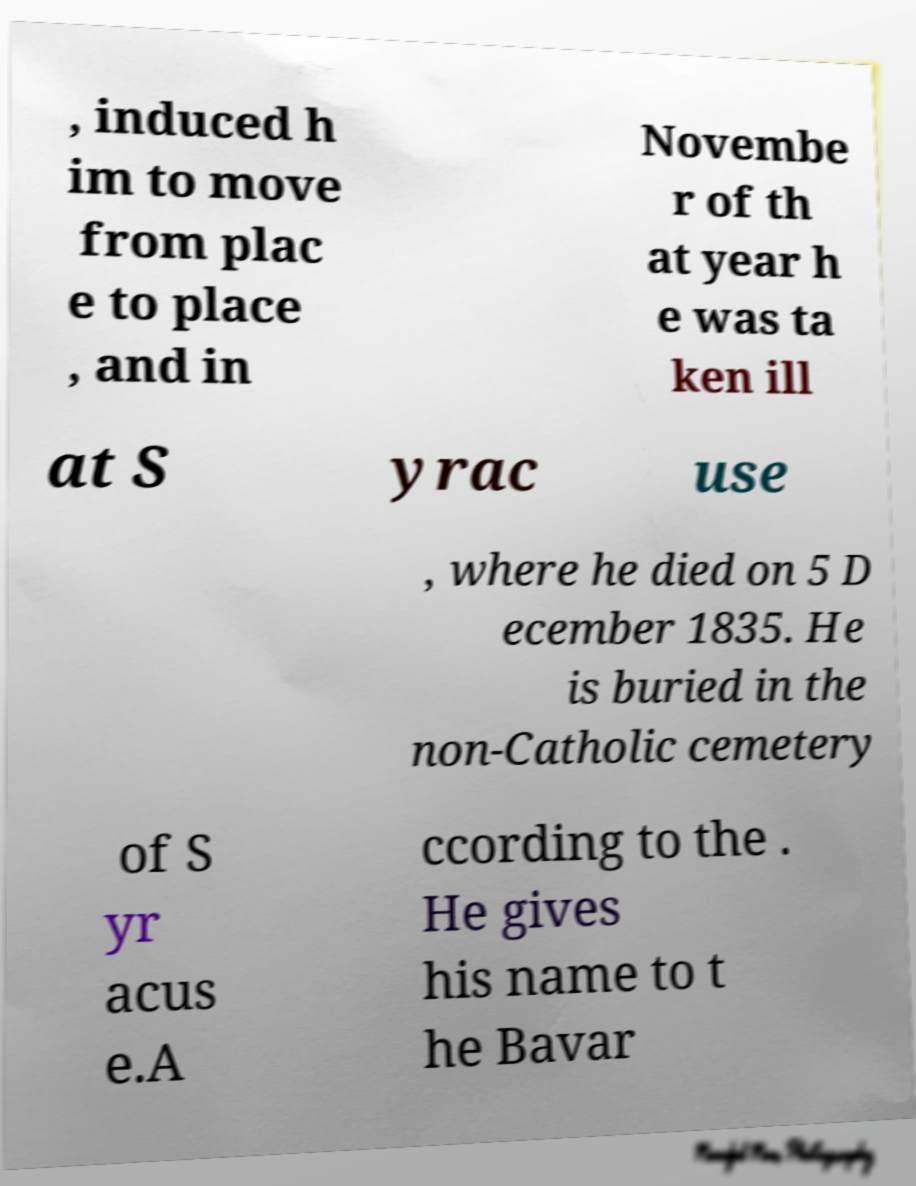There's text embedded in this image that I need extracted. Can you transcribe it verbatim? , induced h im to move from plac e to place , and in Novembe r of th at year h e was ta ken ill at S yrac use , where he died on 5 D ecember 1835. He is buried in the non-Catholic cemetery of S yr acus e.A ccording to the . He gives his name to t he Bavar 